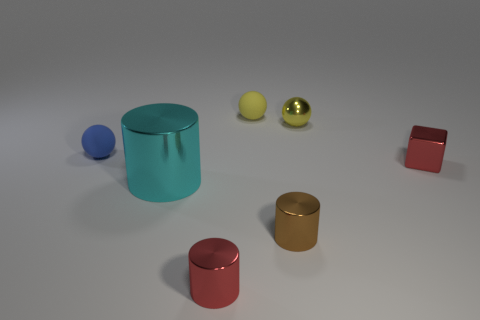How many tiny things are left of the tiny yellow metallic object and in front of the tiny blue sphere?
Keep it short and to the point. 2. What is the material of the red thing left of the brown cylinder to the left of the small red cube that is behind the cyan metallic cylinder?
Offer a very short reply. Metal. What number of small balls have the same material as the large object?
Your answer should be very brief. 1. There is a tiny metallic object that is the same color as the tiny cube; what is its shape?
Provide a succinct answer. Cylinder. There is a yellow matte thing that is the same size as the red metallic block; what shape is it?
Give a very brief answer. Sphere. What is the material of the other tiny ball that is the same color as the metal sphere?
Offer a terse response. Rubber. Are there any shiny things left of the red metal block?
Give a very brief answer. Yes. Is there a tiny yellow metallic thing that has the same shape as the small brown shiny thing?
Provide a succinct answer. No. Do the red object right of the tiny brown thing and the rubber thing right of the big metal cylinder have the same shape?
Ensure brevity in your answer.  No. Is there a green matte sphere of the same size as the brown metal object?
Make the answer very short. No. 